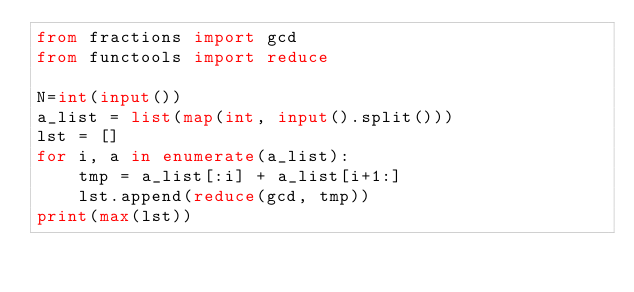<code> <loc_0><loc_0><loc_500><loc_500><_Python_>from fractions import gcd
from functools import reduce
 
N=int(input())
a_list = list(map(int, input().split()))
lst = []
for i, a in enumerate(a_list):
    tmp = a_list[:i] + a_list[i+1:]
    lst.append(reduce(gcd, tmp))
print(max(lst))</code> 